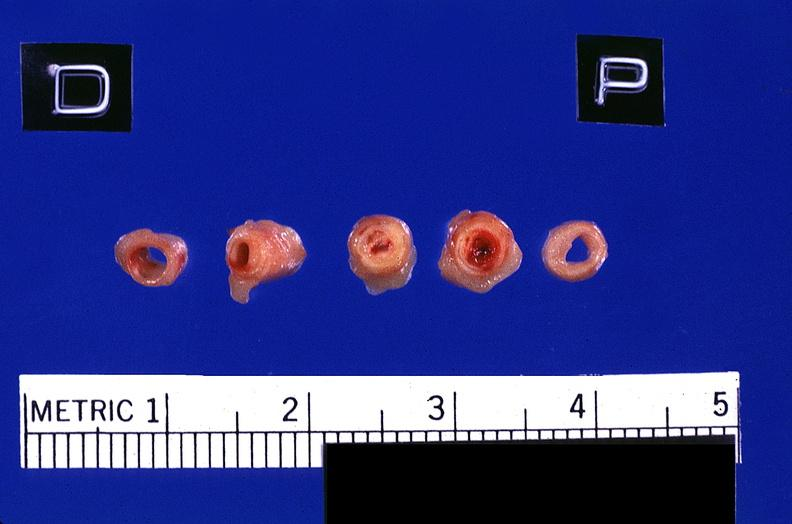how does this image show coronary artery?
Answer the question using a single word or phrase. With atherosclerosis and thrombotic occlusion 